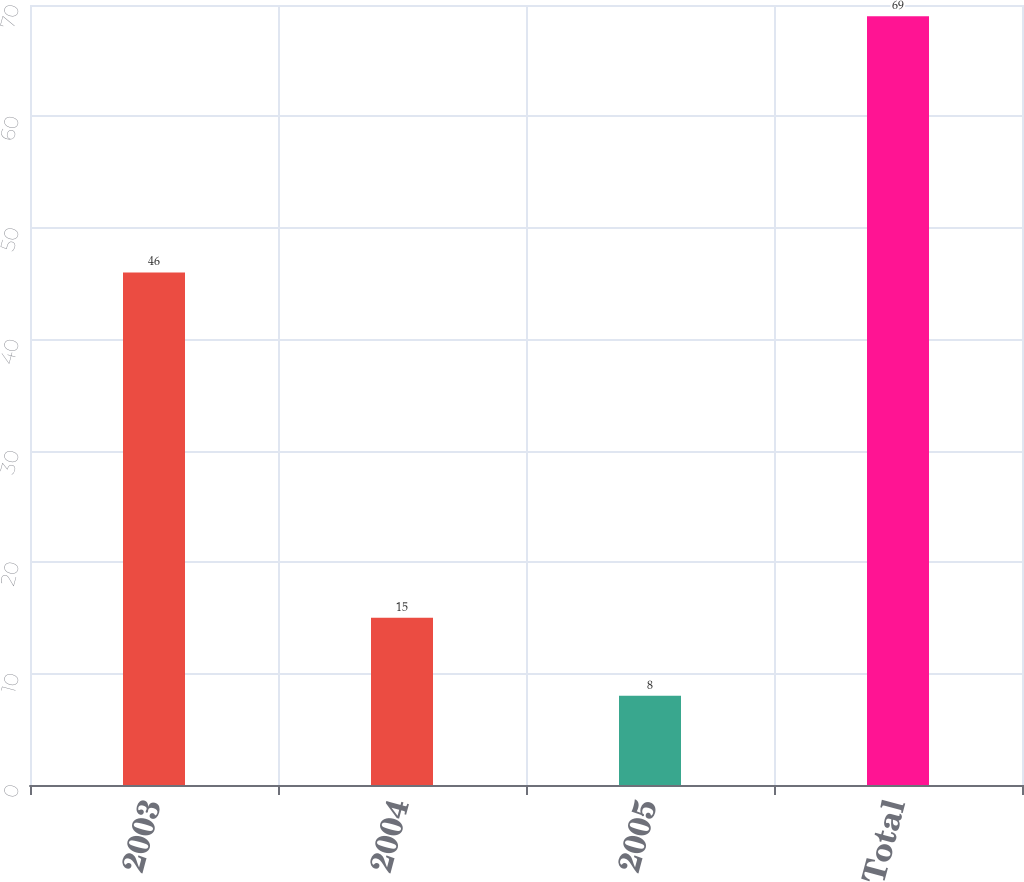Convert chart. <chart><loc_0><loc_0><loc_500><loc_500><bar_chart><fcel>2003<fcel>2004<fcel>2005<fcel>Total<nl><fcel>46<fcel>15<fcel>8<fcel>69<nl></chart> 